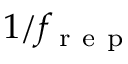<formula> <loc_0><loc_0><loc_500><loc_500>1 / f _ { r e p }</formula> 